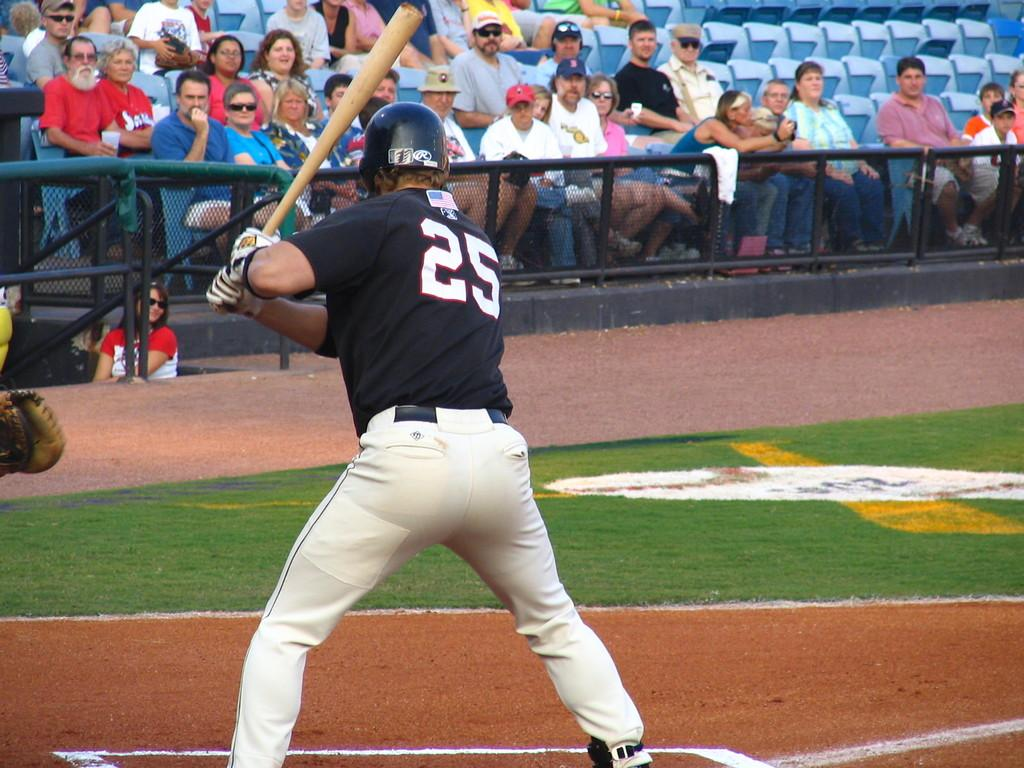<image>
Summarize the visual content of the image. A baseball player wearing number 25 is batting. 